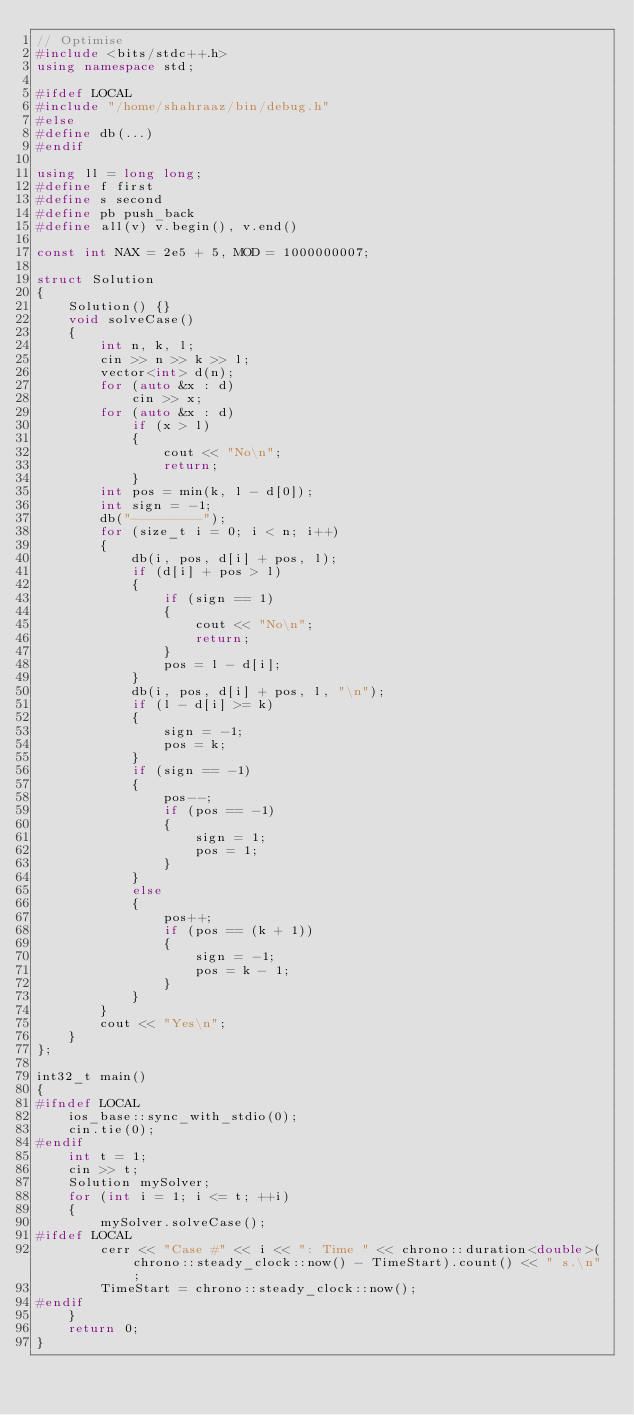<code> <loc_0><loc_0><loc_500><loc_500><_C++_>// Optimise
#include <bits/stdc++.h>
using namespace std;

#ifdef LOCAL
#include "/home/shahraaz/bin/debug.h"
#else
#define db(...)
#endif

using ll = long long;
#define f first
#define s second
#define pb push_back
#define all(v) v.begin(), v.end()

const int NAX = 2e5 + 5, MOD = 1000000007;

struct Solution
{
    Solution() {}
    void solveCase()
    {
        int n, k, l;
        cin >> n >> k >> l;
        vector<int> d(n);
        for (auto &x : d)
            cin >> x;
        for (auto &x : d)
            if (x > l)
            {
                cout << "No\n";
                return;
            }
        int pos = min(k, l - d[0]);
        int sign = -1;
        db("---------");
        for (size_t i = 0; i < n; i++)
        {
            db(i, pos, d[i] + pos, l);
            if (d[i] + pos > l)
            {
                if (sign == 1)
                {
                    cout << "No\n";
                    return;
                }
                pos = l - d[i];
            }
            db(i, pos, d[i] + pos, l, "\n");
            if (l - d[i] >= k)
            {
                sign = -1;
                pos = k;
            }
            if (sign == -1)
            {
                pos--;
                if (pos == -1)
                {
                    sign = 1;
                    pos = 1;
                }
            }
            else
            {
                pos++;
                if (pos == (k + 1))
                {
                    sign = -1;
                    pos = k - 1;
                }
            }
        }
        cout << "Yes\n";
    }
};

int32_t main()
{
#ifndef LOCAL
    ios_base::sync_with_stdio(0);
    cin.tie(0);
#endif
    int t = 1;
    cin >> t;
    Solution mySolver;
    for (int i = 1; i <= t; ++i)
    {
        mySolver.solveCase();
#ifdef LOCAL
        cerr << "Case #" << i << ": Time " << chrono::duration<double>(chrono::steady_clock::now() - TimeStart).count() << " s.\n";
        TimeStart = chrono::steady_clock::now();
#endif
    }
    return 0;
}
</code> 